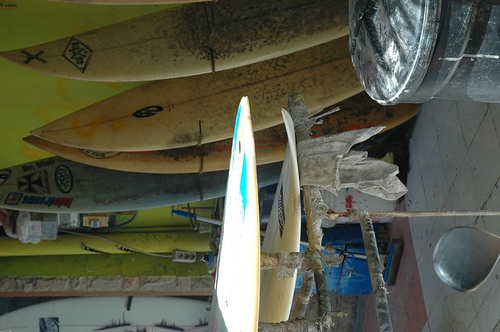Describe the objects in this image and their specific colors. I can see surfboard in darkgreen, olive, black, and gray tones, surfboard in darkgreen, black, and gray tones, surfboard in darkgreen, black, gray, and teal tones, surfboard in darkgreen, white, khaki, gray, and darkgray tones, and surfboard in darkgreen, gray, olive, and darkgray tones in this image. 